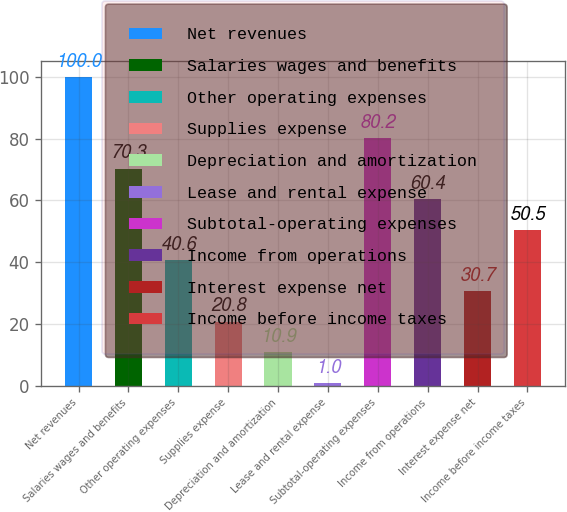Convert chart. <chart><loc_0><loc_0><loc_500><loc_500><bar_chart><fcel>Net revenues<fcel>Salaries wages and benefits<fcel>Other operating expenses<fcel>Supplies expense<fcel>Depreciation and amortization<fcel>Lease and rental expense<fcel>Subtotal-operating expenses<fcel>Income from operations<fcel>Interest expense net<fcel>Income before income taxes<nl><fcel>100<fcel>70.3<fcel>40.6<fcel>20.8<fcel>10.9<fcel>1<fcel>80.2<fcel>60.4<fcel>30.7<fcel>50.5<nl></chart> 